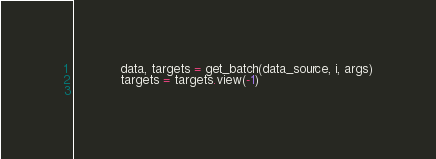<code> <loc_0><loc_0><loc_500><loc_500><_Python_>            data, targets = get_batch(data_source, i, args)
            targets = targets.view(-1)
            </code> 